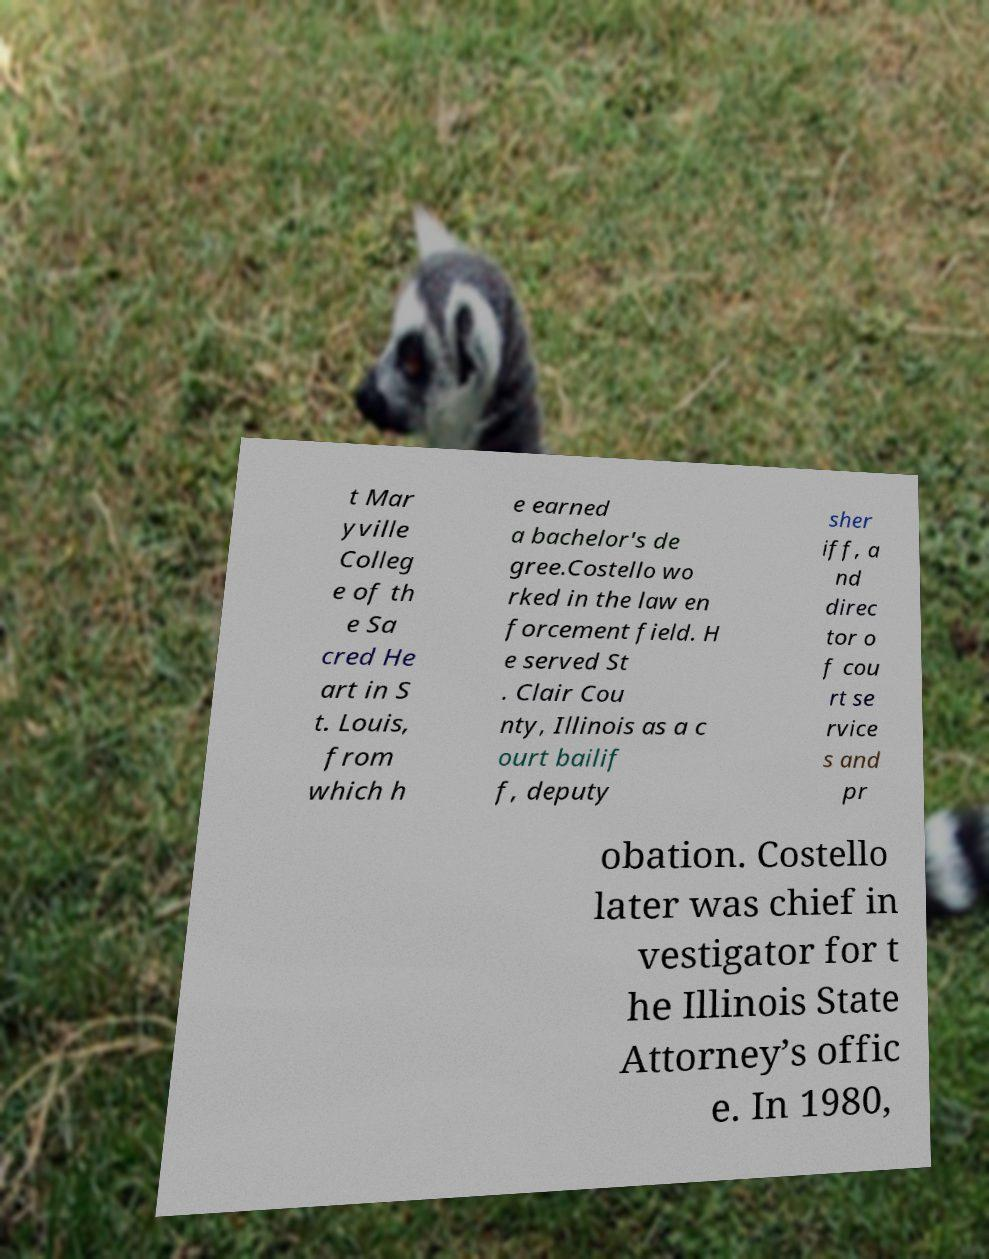Please identify and transcribe the text found in this image. t Mar yville Colleg e of th e Sa cred He art in S t. Louis, from which h e earned a bachelor's de gree.Costello wo rked in the law en forcement field. H e served St . Clair Cou nty, Illinois as a c ourt bailif f, deputy sher iff, a nd direc tor o f cou rt se rvice s and pr obation. Costello later was chief in vestigator for t he Illinois State Attorney’s offic e. In 1980, 